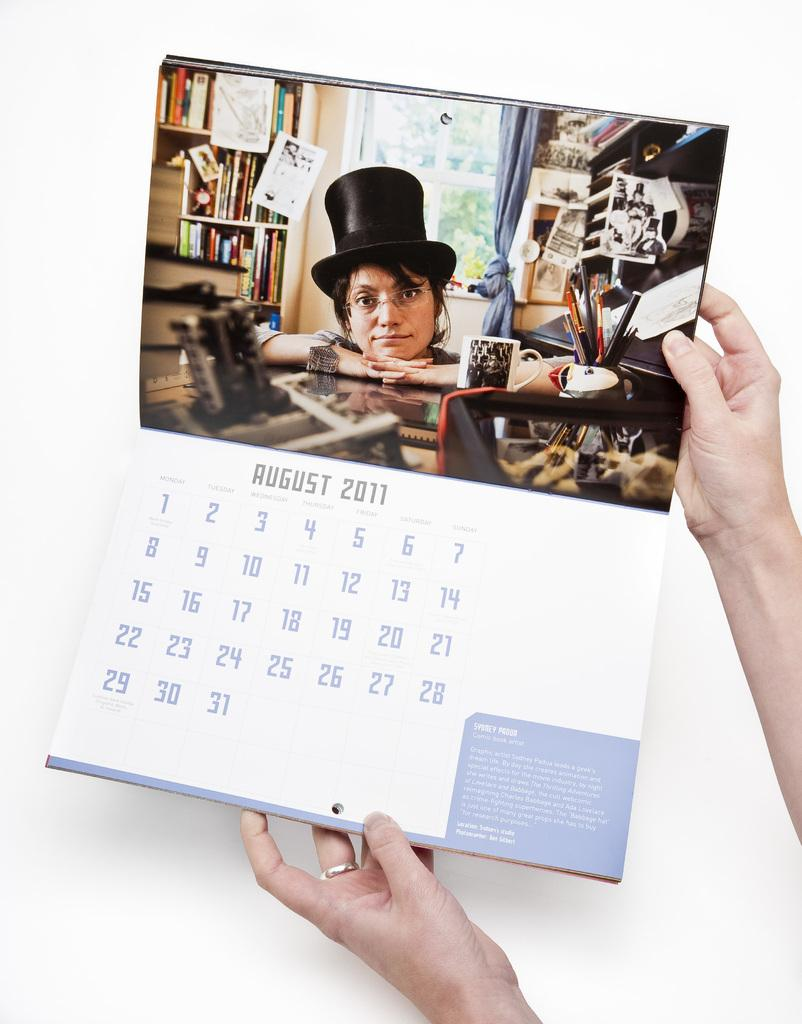What is the main subject of the image? There is a person in the image. What is the person holding in the image? The person's hands are holding a calendar. What type of pencil can be seen in the image? There is no pencil present in the image. 